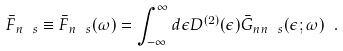<formula> <loc_0><loc_0><loc_500><loc_500>\bar { F } _ { n \ s } \equiv \bar { F } _ { n \ s } ( \omega ) = \int ^ { \infty } _ { - \infty } d \epsilon D ^ { ( 2 ) } ( \epsilon ) \bar { G } _ { n n \ s } ( \epsilon ; \omega ) \ .</formula> 